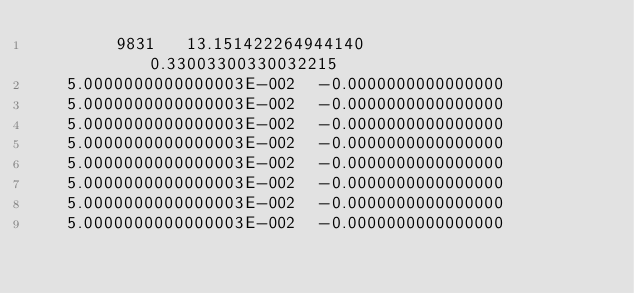Convert code to text. <code><loc_0><loc_0><loc_500><loc_500><_SML_>        9831   13.151422264944140       0.33003300330032215     
   5.0000000000000003E-002  -0.0000000000000000     
   5.0000000000000003E-002  -0.0000000000000000     
   5.0000000000000003E-002  -0.0000000000000000     
   5.0000000000000003E-002  -0.0000000000000000     
   5.0000000000000003E-002  -0.0000000000000000     
   5.0000000000000003E-002  -0.0000000000000000     
   5.0000000000000003E-002  -0.0000000000000000     
   5.0000000000000003E-002  -0.0000000000000000     </code> 